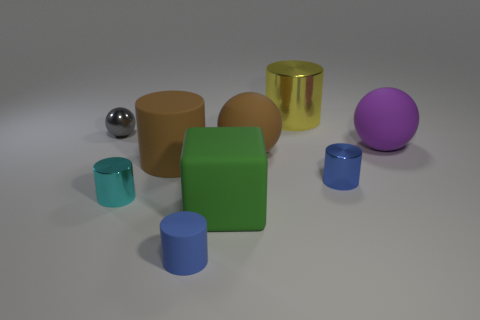The matte cylinder that is the same size as the green rubber thing is what color?
Make the answer very short. Brown. How many other big green rubber objects have the same shape as the large green thing?
Provide a succinct answer. 0. Does the yellow metallic object have the same size as the cylinder that is in front of the big green matte cube?
Give a very brief answer. No. What shape is the blue object that is on the right side of the matte ball that is in front of the purple rubber sphere?
Offer a terse response. Cylinder. Are there fewer matte objects that are to the right of the matte block than large cyan rubber blocks?
Your response must be concise. No. What is the shape of the thing that is the same color as the small matte cylinder?
Offer a terse response. Cylinder. How many cyan cylinders are the same size as the purple thing?
Give a very brief answer. 0. What shape is the tiny cyan object in front of the large purple matte object?
Offer a terse response. Cylinder. Is the number of blue metal objects less than the number of tiny cylinders?
Provide a succinct answer. Yes. Is there anything else that has the same color as the tiny rubber thing?
Your answer should be very brief. Yes. 